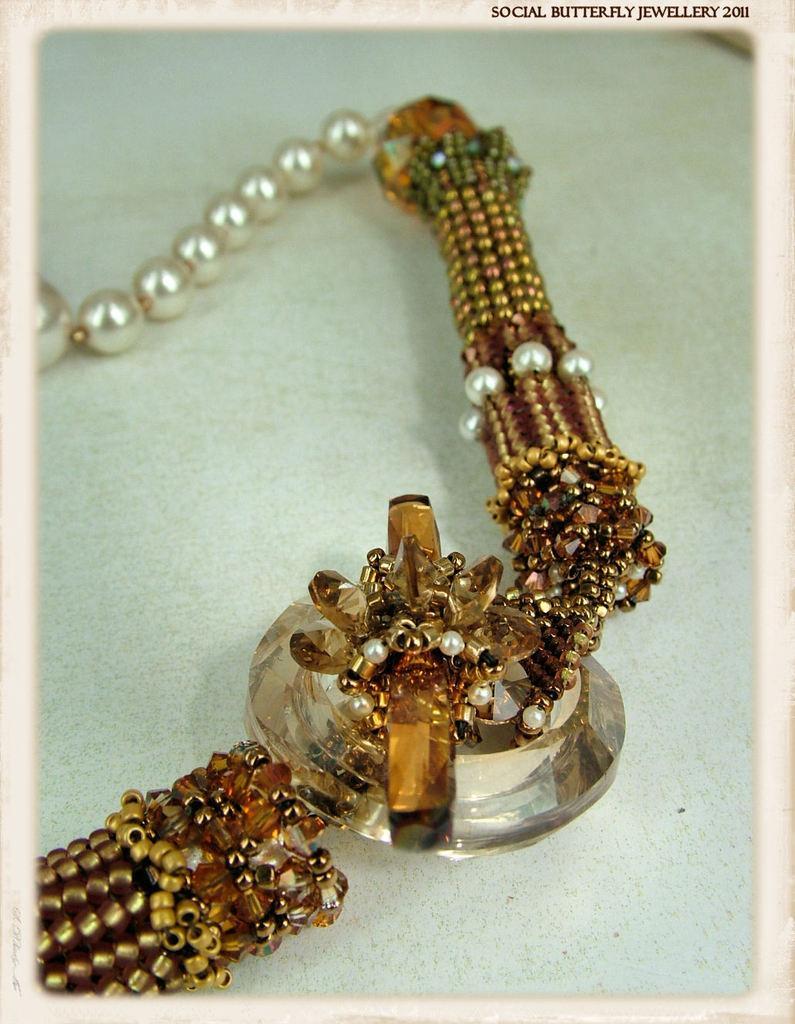In one or two sentences, can you explain what this image depicts? In this image there is a chain kept on the surface. Chain is having few pearls, beads and a stone to it. 